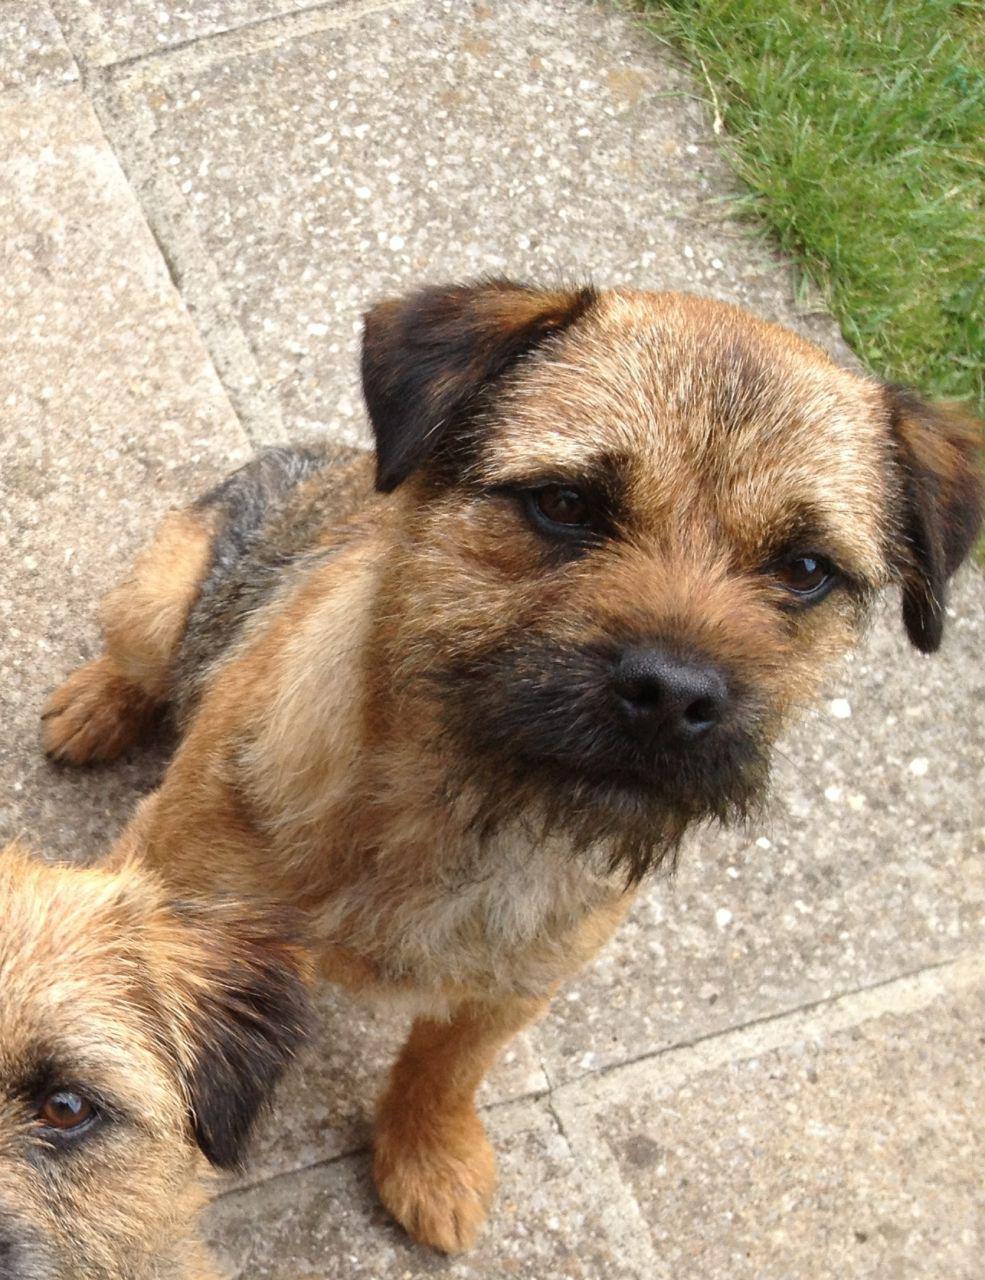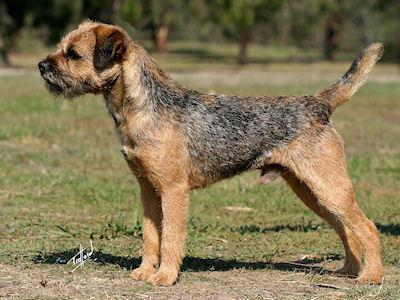The first image is the image on the left, the second image is the image on the right. Examine the images to the left and right. Is the description "In the image to the right, all dogs are standing up." accurate? Answer yes or no. Yes. 